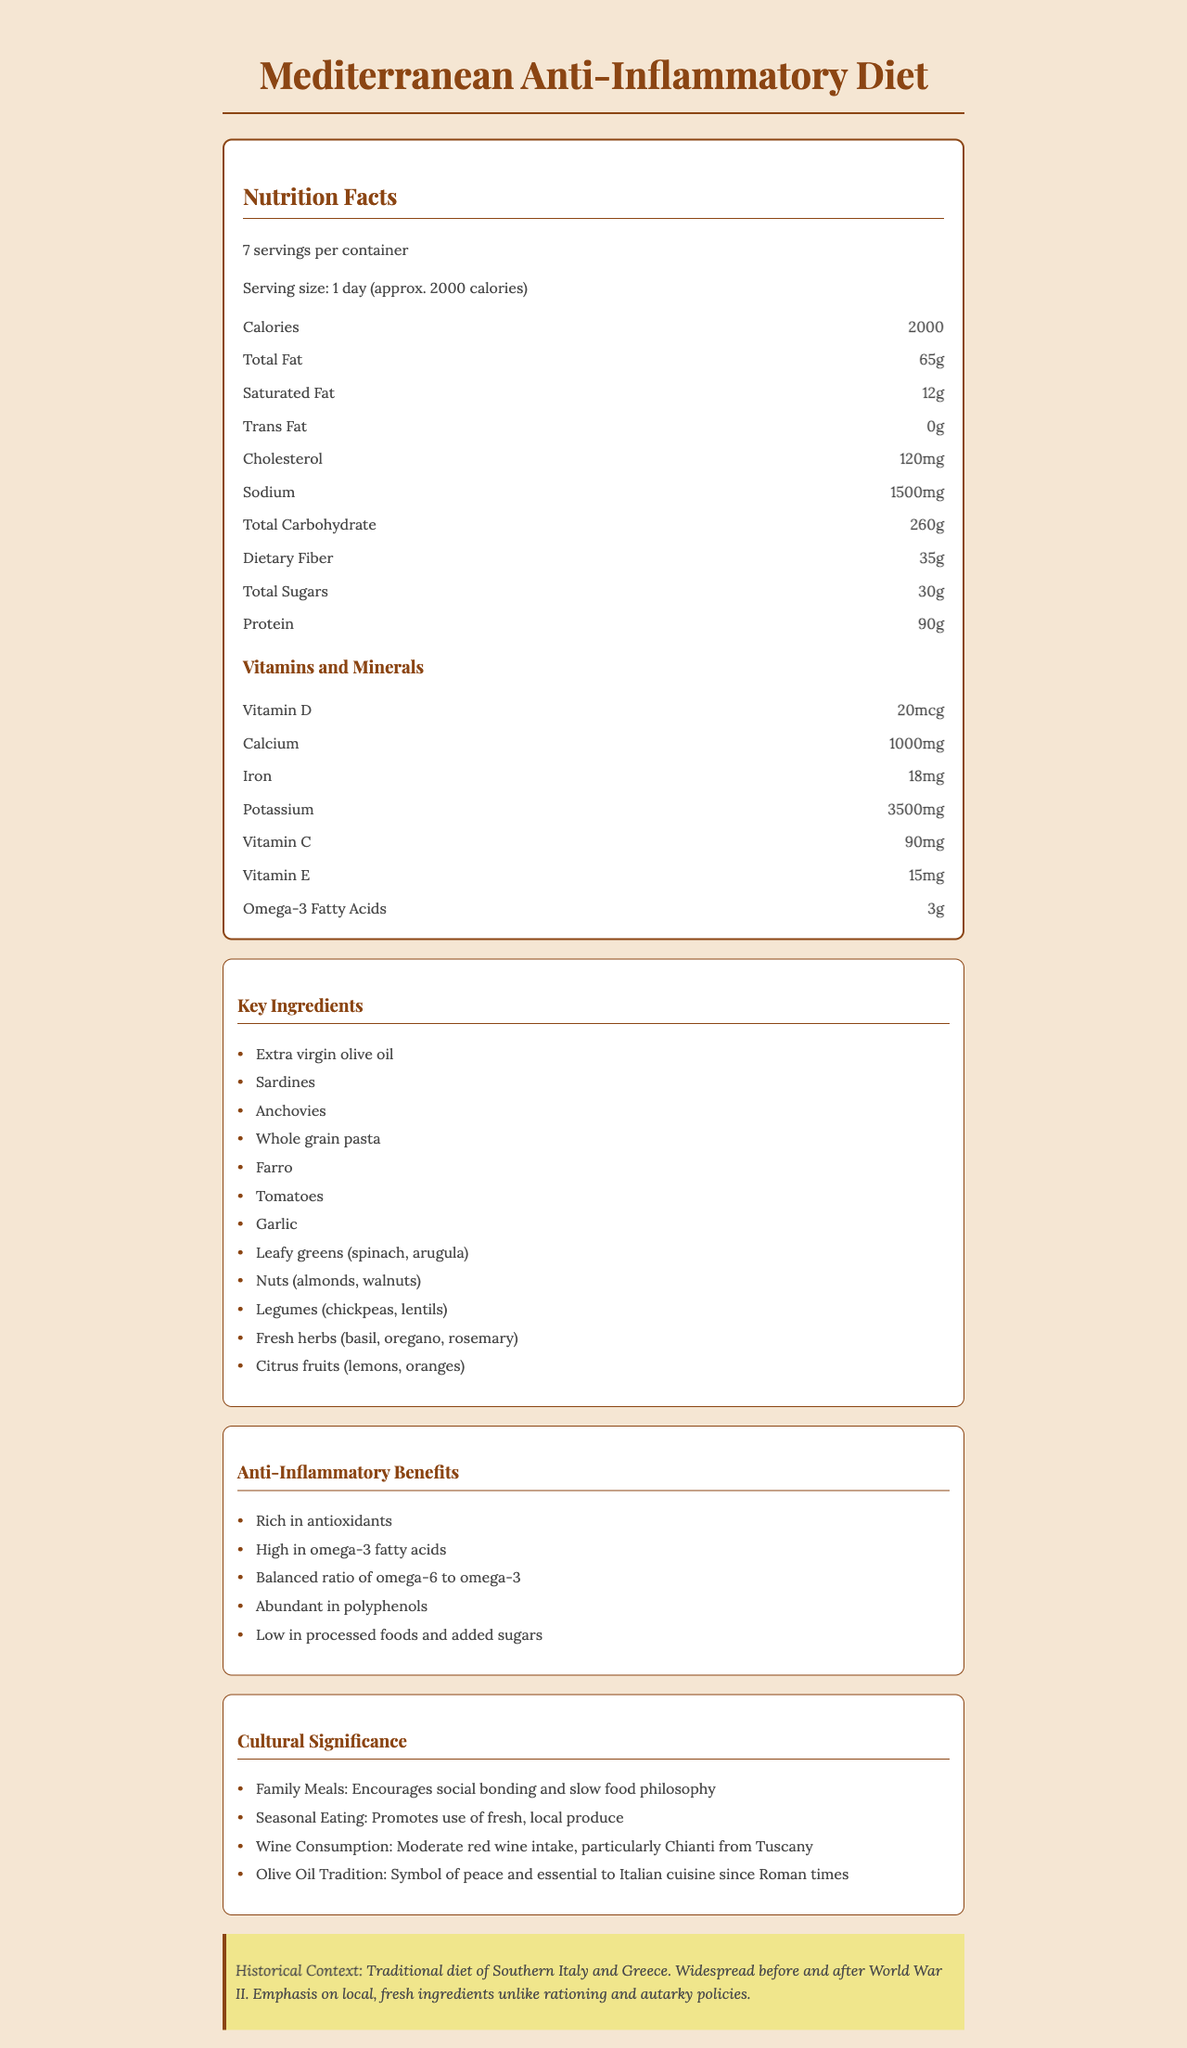what is the serving size? The serving size is listed near the top of the document under the "Nutrition Facts" section.
Answer: 1 day (approx. 2000 calories) how many grams of total fat are in one serving? The nutrition facts section specifies "Total Fat" as 65 grams per serving.
Answer: 65 grams how many servings are in this meal plan container? The document states there are 7 servings per container, also found in the "Nutrition Facts" section.
Answer: 7 servings which ingredient is the primary source of omega-3 fatty acids? Sardines are one of the key ingredients listed, which are known to be a primary source of omega-3 fatty acids.
Answer: Sardines what is the amount of dietary fiber per serving? Dietary fiber is listed as 35 grams per serving in the nutrition facts section.
Answer: 35 grams which vitamin is provided in the highest amount per serving? A. Vitamin D B. Calcium C. Iron D. Vitamin C Calcium is provided in the amount of 1000 mg, which is higher than the amounts given for the other vitamins listed.
Answer: B. Calcium what is the origin of the meal plan described in the document? A. Northern Italy B. Greece C. Southern Italy and Greece D. Spain The historical context section states that the origin is the "Traditional diet of Southern Italy and Greece."
Answer: C. Southern Italy and Greece is the meal plan low in processed foods and added sugars? It is stated under the "Anti-Inflammatory Benefits" section that the diet is low in processed foods and added sugars.
Answer: Yes how is wine consumption described in this meal plan? The cultural significance section mentions moderate red wine consumption, especially Chianti from Tuscany.
Answer: Moderate red wine intake, particularly Chianti from Tuscany summarize the main idea of the document The document outlines the aspects and benefits of a Mediterranean Anti-Inflammatory Diet, aimed at promoting healthier eating habits through traditional foods from Southern Italy and Greece. It includes specific nutritional data, key ingredients, historical context, and cultural practices associated with the diet.
Answer: The document provides an overview of a Mediterranean Anti-Inflammatory Diet meal plan, detailing its nutritional facts, key ingredients, anti-inflammatory benefits, historical context, and cultural significance. It emphasizes the use of fresh and local ingredients, rich in antioxidants and low in processed foods. what are the exact amounts of Vitamin A and Magnesium per serving? The document does not provide specific information regarding the amounts of Vitamin A and Magnesium per serving.
Answer: Not enough information 